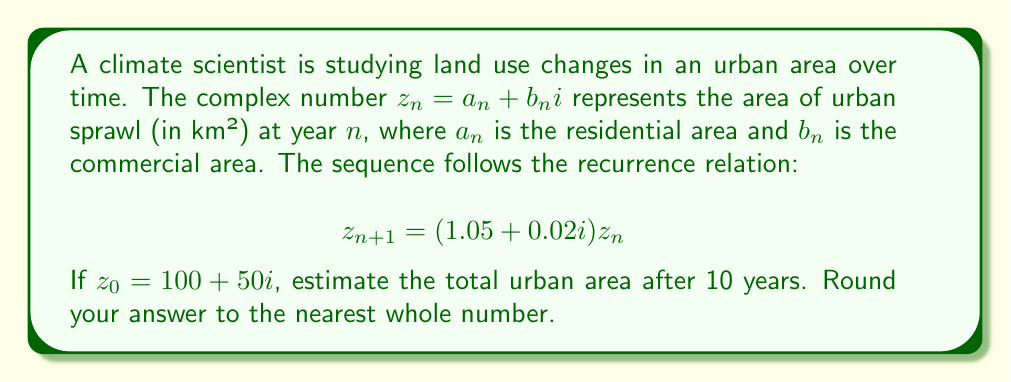Give your solution to this math problem. To solve this problem, we need to iterate the recurrence relation 10 times:

1) First, let's define $c = 1.05 + 0.02i$ as our growth factor.

2) We can express $z_n$ as:
   $$z_n = c^n z_0$$

3) After 10 years, we have:
   $$z_{10} = c^{10} z_0$$

4) Let's calculate $c^{10}$:
   $$c^{10} = (1.05 + 0.02i)^{10}$$

5) Using De Moivre's formula: $(r(\cos\theta + i\sin\theta))^n = r^n(\cos(n\theta) + i\sin(n\theta))$
   Where $r = \sqrt{1.05^2 + 0.02^2} \approx 1.0502$ and $\theta = \arctan(0.02/1.05) \approx 0.0190$

6) $c^{10} \approx 1.0502^{10}(\cos(10 \cdot 0.0190) + i\sin(10 \cdot 0.0190))$
   $\approx 1.6288 + 0.3101i$

7) Now, $z_{10} = (1.6288 + 0.3101i)(100 + 50i)$
   $= (162.88 + 31.01i)(100 + 50i)$
   $= 16288 + 3101i + 8144i + 1550.5$
   $= 17838.5 + 11245i$

8) The total urban area is the magnitude of this complex number:
   $|z_{10}| = \sqrt{17838.5^2 + 11245^2} \approx 21070.7$

9) Rounding to the nearest whole number: 21071 km²
Answer: 21071 km² 